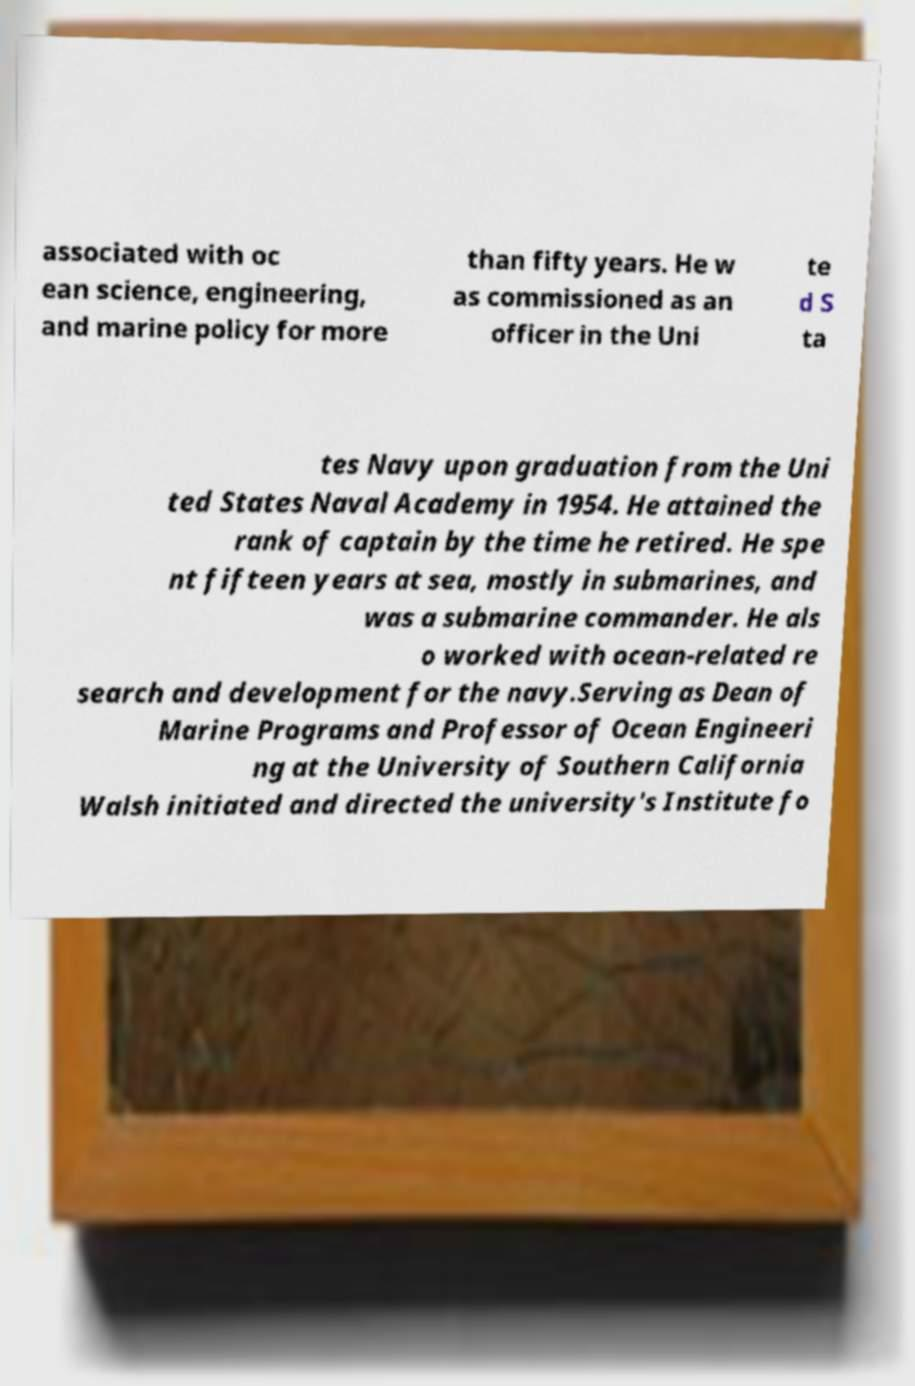Can you read and provide the text displayed in the image?This photo seems to have some interesting text. Can you extract and type it out for me? associated with oc ean science, engineering, and marine policy for more than fifty years. He w as commissioned as an officer in the Uni te d S ta tes Navy upon graduation from the Uni ted States Naval Academy in 1954. He attained the rank of captain by the time he retired. He spe nt fifteen years at sea, mostly in submarines, and was a submarine commander. He als o worked with ocean-related re search and development for the navy.Serving as Dean of Marine Programs and Professor of Ocean Engineeri ng at the University of Southern California Walsh initiated and directed the university's Institute fo 